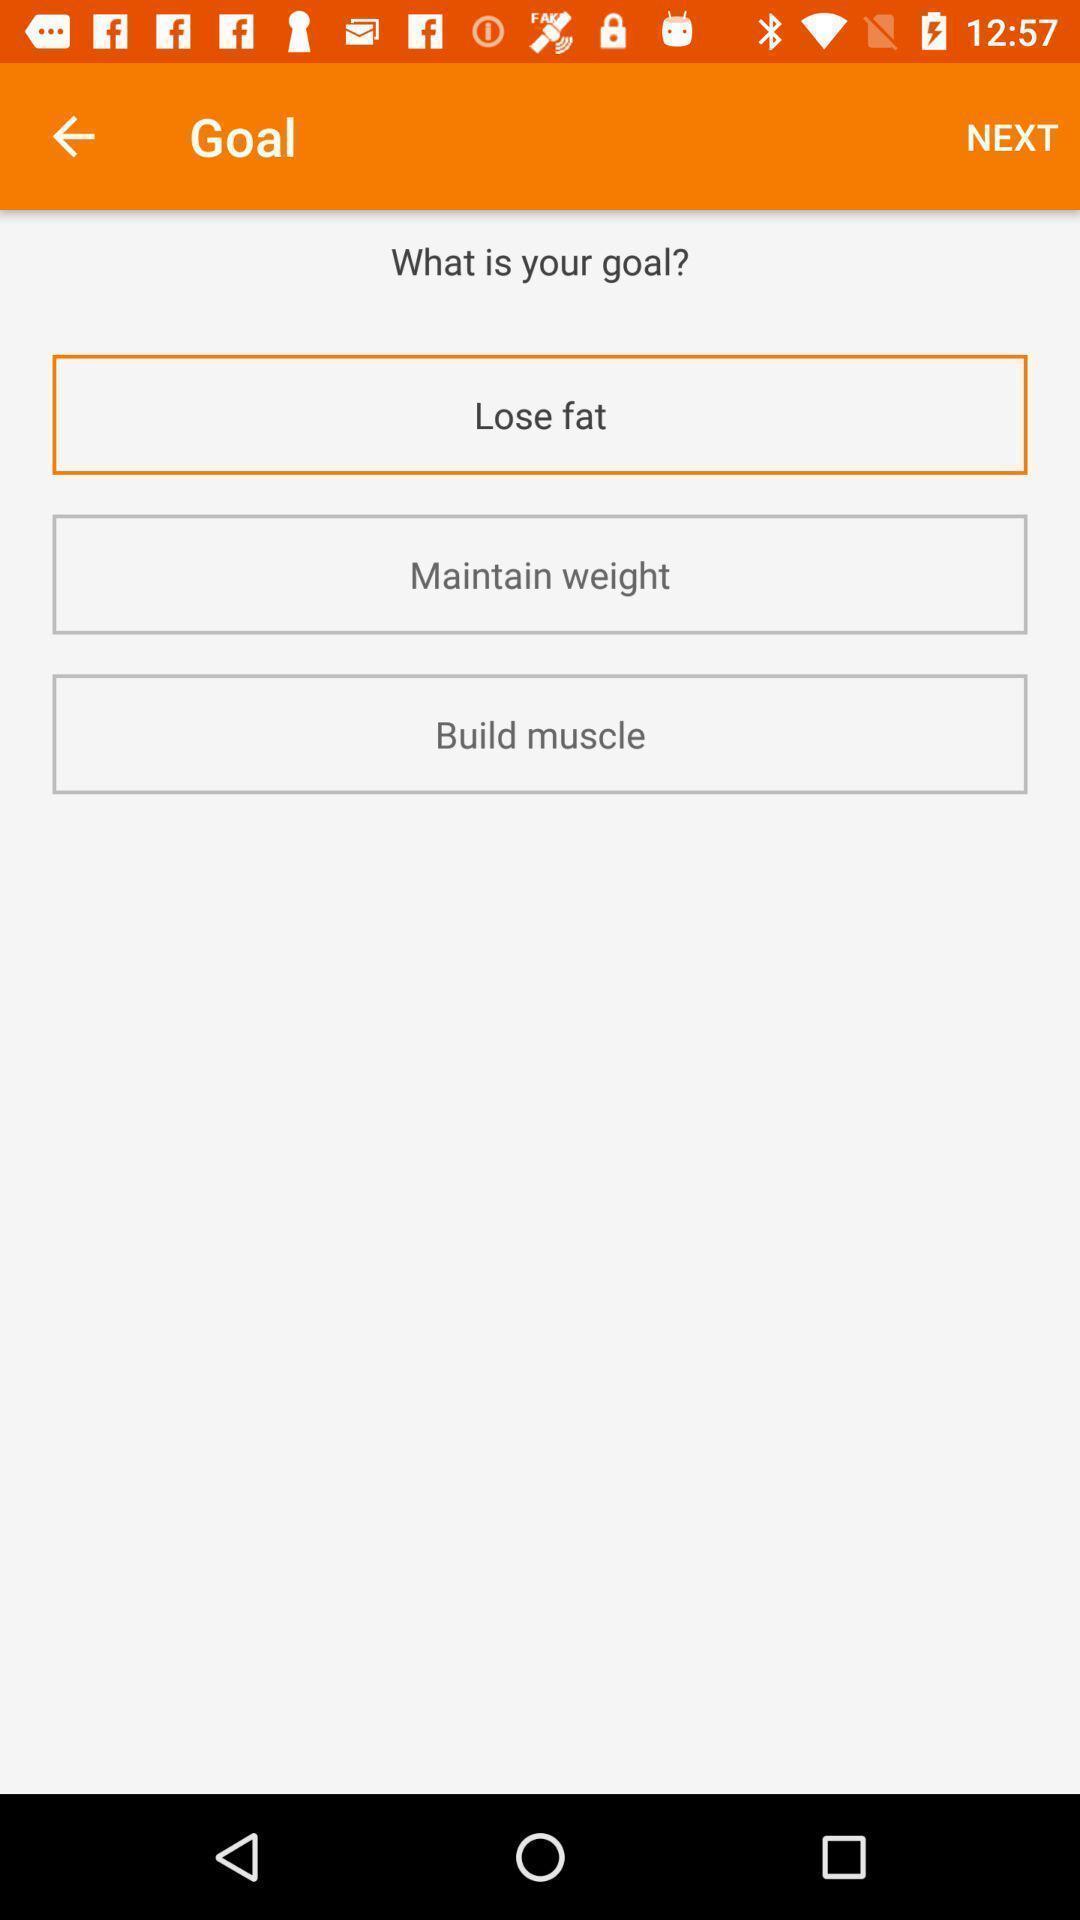Explain the elements present in this screenshot. Window displaying a meal planner app. 